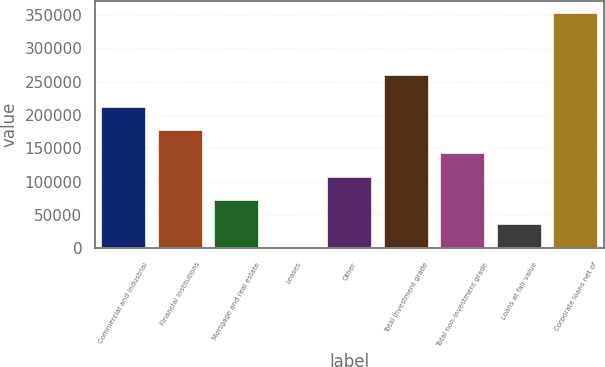Convert chart to OTSL. <chart><loc_0><loc_0><loc_500><loc_500><bar_chart><fcel>Commercial and industrial<fcel>Financial institutions<fcel>Mortgage and real estate<fcel>Leases<fcel>Other<fcel>Total investment grade<fcel>Total non-investment grade<fcel>Loans at fair value<fcel>Corporate loans net of<nl><fcel>212640<fcel>177372<fcel>71570.6<fcel>1036<fcel>106838<fcel>259992<fcel>142105<fcel>36303.3<fcel>353709<nl></chart> 